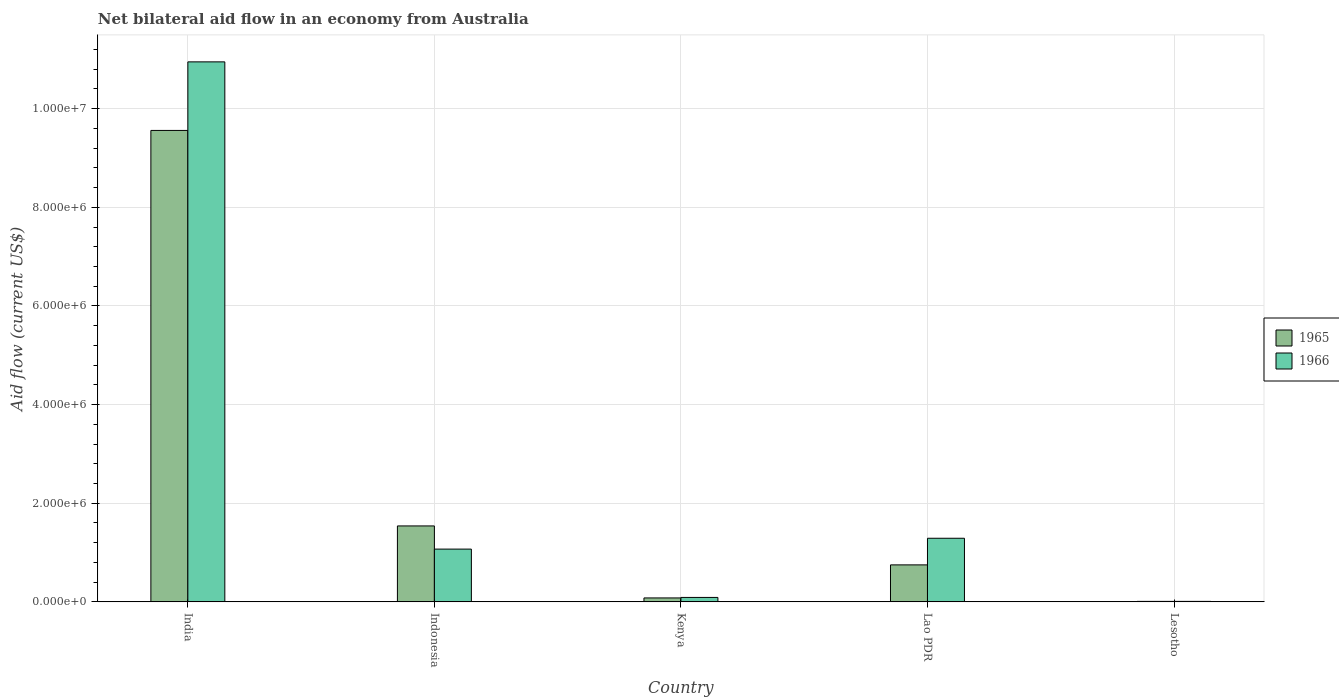How many different coloured bars are there?
Offer a terse response. 2. How many groups of bars are there?
Provide a short and direct response. 5. What is the label of the 3rd group of bars from the left?
Provide a succinct answer. Kenya. In how many cases, is the number of bars for a given country not equal to the number of legend labels?
Offer a very short reply. 0. What is the net bilateral aid flow in 1965 in India?
Provide a succinct answer. 9.56e+06. Across all countries, what is the maximum net bilateral aid flow in 1966?
Your response must be concise. 1.10e+07. Across all countries, what is the minimum net bilateral aid flow in 1966?
Ensure brevity in your answer.  10000. In which country was the net bilateral aid flow in 1966 minimum?
Your answer should be compact. Lesotho. What is the total net bilateral aid flow in 1966 in the graph?
Your answer should be compact. 1.34e+07. What is the difference between the net bilateral aid flow in 1965 in India and that in Lao PDR?
Ensure brevity in your answer.  8.81e+06. What is the difference between the net bilateral aid flow in 1965 in Kenya and the net bilateral aid flow in 1966 in Lesotho?
Your response must be concise. 7.00e+04. What is the average net bilateral aid flow in 1965 per country?
Make the answer very short. 2.39e+06. What is the difference between the net bilateral aid flow of/in 1966 and net bilateral aid flow of/in 1965 in Indonesia?
Offer a very short reply. -4.70e+05. In how many countries, is the net bilateral aid flow in 1965 greater than 8000000 US$?
Your answer should be compact. 1. What is the ratio of the net bilateral aid flow in 1966 in Indonesia to that in Lao PDR?
Give a very brief answer. 0.83. Is the difference between the net bilateral aid flow in 1966 in Kenya and Lesotho greater than the difference between the net bilateral aid flow in 1965 in Kenya and Lesotho?
Your answer should be very brief. Yes. What is the difference between the highest and the second highest net bilateral aid flow in 1965?
Provide a short and direct response. 8.81e+06. What is the difference between the highest and the lowest net bilateral aid flow in 1965?
Provide a succinct answer. 9.55e+06. In how many countries, is the net bilateral aid flow in 1966 greater than the average net bilateral aid flow in 1966 taken over all countries?
Ensure brevity in your answer.  1. Is the sum of the net bilateral aid flow in 1966 in Indonesia and Lesotho greater than the maximum net bilateral aid flow in 1965 across all countries?
Offer a very short reply. No. What does the 1st bar from the left in Kenya represents?
Make the answer very short. 1965. What does the 1st bar from the right in Kenya represents?
Provide a succinct answer. 1966. Are all the bars in the graph horizontal?
Provide a short and direct response. No. How many countries are there in the graph?
Your answer should be compact. 5. What is the difference between two consecutive major ticks on the Y-axis?
Offer a very short reply. 2.00e+06. Where does the legend appear in the graph?
Your response must be concise. Center right. How many legend labels are there?
Keep it short and to the point. 2. What is the title of the graph?
Your answer should be compact. Net bilateral aid flow in an economy from Australia. What is the Aid flow (current US$) in 1965 in India?
Offer a terse response. 9.56e+06. What is the Aid flow (current US$) in 1966 in India?
Ensure brevity in your answer.  1.10e+07. What is the Aid flow (current US$) in 1965 in Indonesia?
Provide a short and direct response. 1.54e+06. What is the Aid flow (current US$) in 1966 in Indonesia?
Ensure brevity in your answer.  1.07e+06. What is the Aid flow (current US$) of 1965 in Lao PDR?
Your answer should be compact. 7.50e+05. What is the Aid flow (current US$) of 1966 in Lao PDR?
Your response must be concise. 1.29e+06. What is the Aid flow (current US$) in 1966 in Lesotho?
Your answer should be compact. 10000. Across all countries, what is the maximum Aid flow (current US$) in 1965?
Ensure brevity in your answer.  9.56e+06. Across all countries, what is the maximum Aid flow (current US$) in 1966?
Offer a terse response. 1.10e+07. Across all countries, what is the minimum Aid flow (current US$) in 1965?
Provide a succinct answer. 10000. Across all countries, what is the minimum Aid flow (current US$) of 1966?
Ensure brevity in your answer.  10000. What is the total Aid flow (current US$) in 1965 in the graph?
Your answer should be very brief. 1.19e+07. What is the total Aid flow (current US$) of 1966 in the graph?
Provide a short and direct response. 1.34e+07. What is the difference between the Aid flow (current US$) of 1965 in India and that in Indonesia?
Your answer should be very brief. 8.02e+06. What is the difference between the Aid flow (current US$) of 1966 in India and that in Indonesia?
Ensure brevity in your answer.  9.88e+06. What is the difference between the Aid flow (current US$) in 1965 in India and that in Kenya?
Provide a short and direct response. 9.48e+06. What is the difference between the Aid flow (current US$) in 1966 in India and that in Kenya?
Your answer should be compact. 1.09e+07. What is the difference between the Aid flow (current US$) in 1965 in India and that in Lao PDR?
Make the answer very short. 8.81e+06. What is the difference between the Aid flow (current US$) of 1966 in India and that in Lao PDR?
Provide a short and direct response. 9.66e+06. What is the difference between the Aid flow (current US$) of 1965 in India and that in Lesotho?
Provide a short and direct response. 9.55e+06. What is the difference between the Aid flow (current US$) in 1966 in India and that in Lesotho?
Your answer should be compact. 1.09e+07. What is the difference between the Aid flow (current US$) of 1965 in Indonesia and that in Kenya?
Your answer should be very brief. 1.46e+06. What is the difference between the Aid flow (current US$) of 1966 in Indonesia and that in Kenya?
Ensure brevity in your answer.  9.80e+05. What is the difference between the Aid flow (current US$) of 1965 in Indonesia and that in Lao PDR?
Give a very brief answer. 7.90e+05. What is the difference between the Aid flow (current US$) of 1966 in Indonesia and that in Lao PDR?
Your answer should be compact. -2.20e+05. What is the difference between the Aid flow (current US$) of 1965 in Indonesia and that in Lesotho?
Your response must be concise. 1.53e+06. What is the difference between the Aid flow (current US$) in 1966 in Indonesia and that in Lesotho?
Provide a succinct answer. 1.06e+06. What is the difference between the Aid flow (current US$) in 1965 in Kenya and that in Lao PDR?
Keep it short and to the point. -6.70e+05. What is the difference between the Aid flow (current US$) of 1966 in Kenya and that in Lao PDR?
Your response must be concise. -1.20e+06. What is the difference between the Aid flow (current US$) of 1966 in Kenya and that in Lesotho?
Your answer should be very brief. 8.00e+04. What is the difference between the Aid flow (current US$) in 1965 in Lao PDR and that in Lesotho?
Offer a very short reply. 7.40e+05. What is the difference between the Aid flow (current US$) of 1966 in Lao PDR and that in Lesotho?
Make the answer very short. 1.28e+06. What is the difference between the Aid flow (current US$) in 1965 in India and the Aid flow (current US$) in 1966 in Indonesia?
Offer a very short reply. 8.49e+06. What is the difference between the Aid flow (current US$) of 1965 in India and the Aid flow (current US$) of 1966 in Kenya?
Offer a very short reply. 9.47e+06. What is the difference between the Aid flow (current US$) in 1965 in India and the Aid flow (current US$) in 1966 in Lao PDR?
Ensure brevity in your answer.  8.27e+06. What is the difference between the Aid flow (current US$) in 1965 in India and the Aid flow (current US$) in 1966 in Lesotho?
Keep it short and to the point. 9.55e+06. What is the difference between the Aid flow (current US$) in 1965 in Indonesia and the Aid flow (current US$) in 1966 in Kenya?
Give a very brief answer. 1.45e+06. What is the difference between the Aid flow (current US$) of 1965 in Indonesia and the Aid flow (current US$) of 1966 in Lao PDR?
Your response must be concise. 2.50e+05. What is the difference between the Aid flow (current US$) of 1965 in Indonesia and the Aid flow (current US$) of 1966 in Lesotho?
Your response must be concise. 1.53e+06. What is the difference between the Aid flow (current US$) in 1965 in Kenya and the Aid flow (current US$) in 1966 in Lao PDR?
Give a very brief answer. -1.21e+06. What is the difference between the Aid flow (current US$) of 1965 in Kenya and the Aid flow (current US$) of 1966 in Lesotho?
Offer a terse response. 7.00e+04. What is the difference between the Aid flow (current US$) of 1965 in Lao PDR and the Aid flow (current US$) of 1966 in Lesotho?
Provide a succinct answer. 7.40e+05. What is the average Aid flow (current US$) in 1965 per country?
Your response must be concise. 2.39e+06. What is the average Aid flow (current US$) in 1966 per country?
Your answer should be compact. 2.68e+06. What is the difference between the Aid flow (current US$) in 1965 and Aid flow (current US$) in 1966 in India?
Your answer should be very brief. -1.39e+06. What is the difference between the Aid flow (current US$) of 1965 and Aid flow (current US$) of 1966 in Kenya?
Ensure brevity in your answer.  -10000. What is the difference between the Aid flow (current US$) of 1965 and Aid flow (current US$) of 1966 in Lao PDR?
Your answer should be very brief. -5.40e+05. What is the difference between the Aid flow (current US$) in 1965 and Aid flow (current US$) in 1966 in Lesotho?
Make the answer very short. 0. What is the ratio of the Aid flow (current US$) of 1965 in India to that in Indonesia?
Offer a terse response. 6.21. What is the ratio of the Aid flow (current US$) in 1966 in India to that in Indonesia?
Provide a short and direct response. 10.23. What is the ratio of the Aid flow (current US$) of 1965 in India to that in Kenya?
Ensure brevity in your answer.  119.5. What is the ratio of the Aid flow (current US$) of 1966 in India to that in Kenya?
Your response must be concise. 121.67. What is the ratio of the Aid flow (current US$) in 1965 in India to that in Lao PDR?
Provide a short and direct response. 12.75. What is the ratio of the Aid flow (current US$) of 1966 in India to that in Lao PDR?
Keep it short and to the point. 8.49. What is the ratio of the Aid flow (current US$) of 1965 in India to that in Lesotho?
Your answer should be compact. 956. What is the ratio of the Aid flow (current US$) in 1966 in India to that in Lesotho?
Make the answer very short. 1095. What is the ratio of the Aid flow (current US$) in 1965 in Indonesia to that in Kenya?
Your response must be concise. 19.25. What is the ratio of the Aid flow (current US$) in 1966 in Indonesia to that in Kenya?
Provide a short and direct response. 11.89. What is the ratio of the Aid flow (current US$) of 1965 in Indonesia to that in Lao PDR?
Offer a terse response. 2.05. What is the ratio of the Aid flow (current US$) in 1966 in Indonesia to that in Lao PDR?
Offer a terse response. 0.83. What is the ratio of the Aid flow (current US$) in 1965 in Indonesia to that in Lesotho?
Offer a terse response. 154. What is the ratio of the Aid flow (current US$) of 1966 in Indonesia to that in Lesotho?
Make the answer very short. 107. What is the ratio of the Aid flow (current US$) in 1965 in Kenya to that in Lao PDR?
Your answer should be very brief. 0.11. What is the ratio of the Aid flow (current US$) of 1966 in Kenya to that in Lao PDR?
Give a very brief answer. 0.07. What is the ratio of the Aid flow (current US$) in 1965 in Kenya to that in Lesotho?
Your answer should be compact. 8. What is the ratio of the Aid flow (current US$) of 1966 in Lao PDR to that in Lesotho?
Ensure brevity in your answer.  129. What is the difference between the highest and the second highest Aid flow (current US$) in 1965?
Provide a succinct answer. 8.02e+06. What is the difference between the highest and the second highest Aid flow (current US$) of 1966?
Provide a short and direct response. 9.66e+06. What is the difference between the highest and the lowest Aid flow (current US$) of 1965?
Make the answer very short. 9.55e+06. What is the difference between the highest and the lowest Aid flow (current US$) in 1966?
Offer a very short reply. 1.09e+07. 